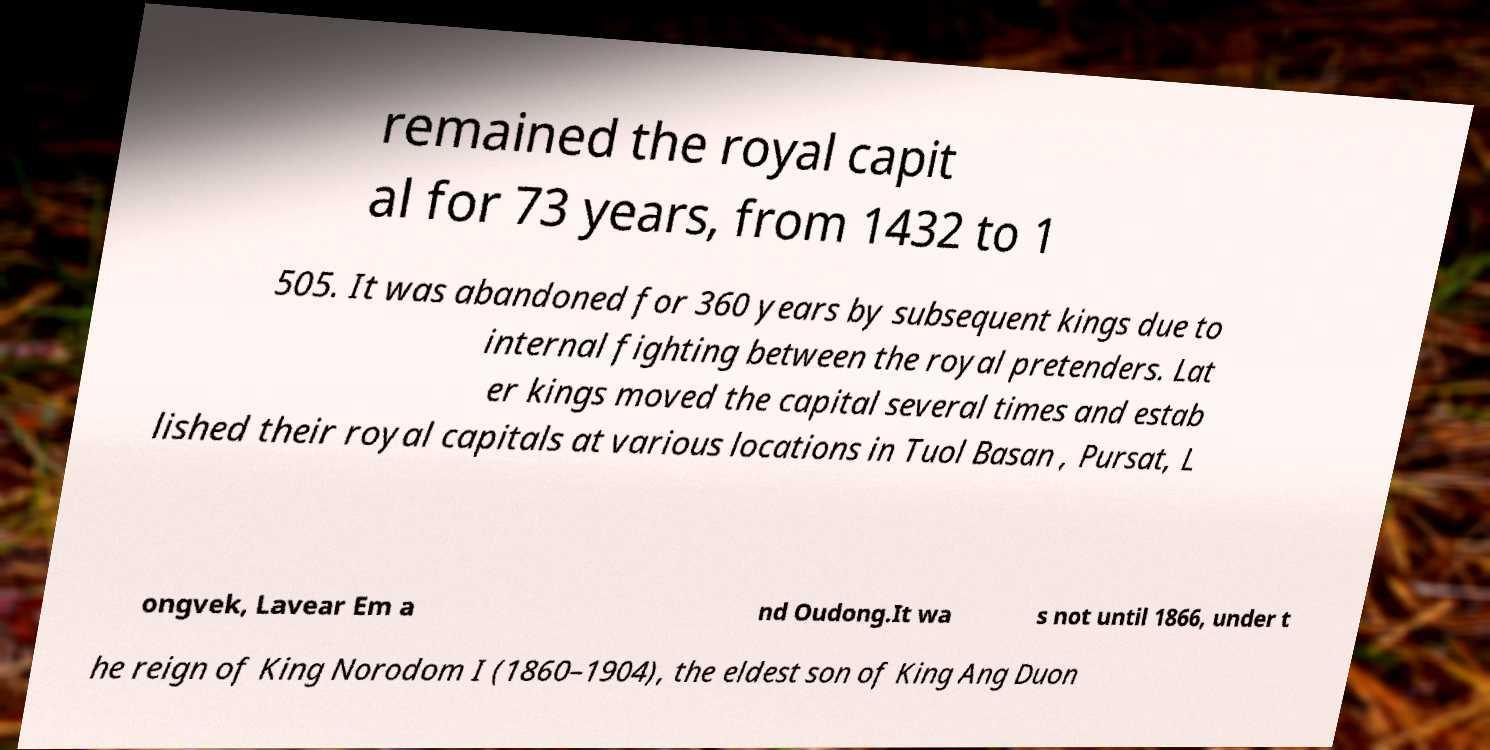Can you accurately transcribe the text from the provided image for me? remained the royal capit al for 73 years, from 1432 to 1 505. It was abandoned for 360 years by subsequent kings due to internal fighting between the royal pretenders. Lat er kings moved the capital several times and estab lished their royal capitals at various locations in Tuol Basan , Pursat, L ongvek, Lavear Em a nd Oudong.It wa s not until 1866, under t he reign of King Norodom I (1860–1904), the eldest son of King Ang Duon 